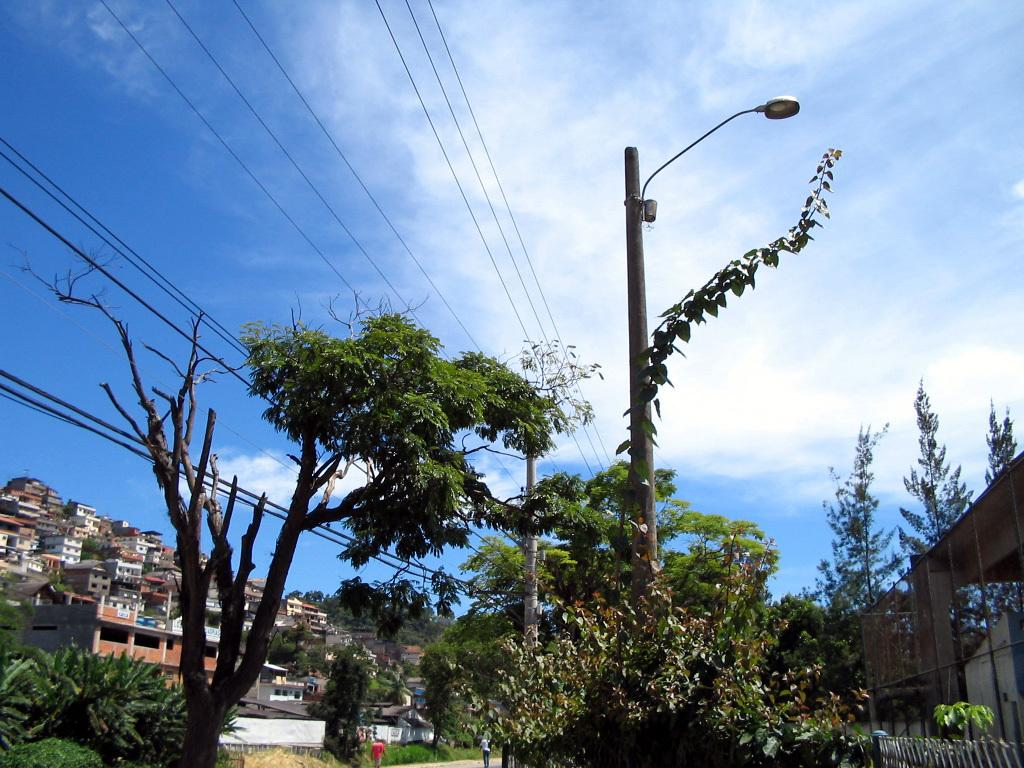What is located in the center of the image? There are trees in the center of the image. What objects can be seen in the image besides the trees? There are poles in the image. What can be seen in the background of the image? There are buildings, the sky, and wires visible in the background. What structure is on the right side of the image? There is a shed on the right side of the image. What type of hose is being used by the brother in the image? There is no brother or hose present in the image. On which side of the shed is the hose connected in the image? There is no hose present in the image, so it cannot be connected to the shed. 